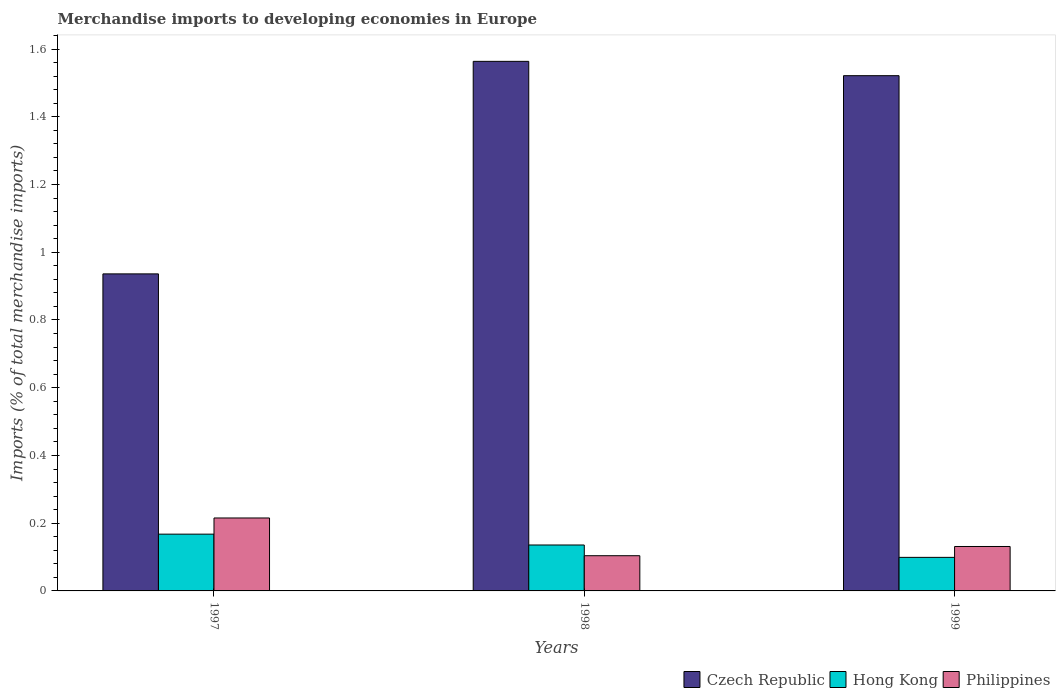How many different coloured bars are there?
Your response must be concise. 3. How many bars are there on the 2nd tick from the right?
Make the answer very short. 3. What is the percentage total merchandise imports in Philippines in 1997?
Provide a short and direct response. 0.22. Across all years, what is the maximum percentage total merchandise imports in Philippines?
Offer a very short reply. 0.22. Across all years, what is the minimum percentage total merchandise imports in Hong Kong?
Keep it short and to the point. 0.1. In which year was the percentage total merchandise imports in Hong Kong maximum?
Give a very brief answer. 1997. What is the total percentage total merchandise imports in Czech Republic in the graph?
Provide a short and direct response. 4.02. What is the difference between the percentage total merchandise imports in Czech Republic in 1997 and that in 1998?
Your answer should be very brief. -0.63. What is the difference between the percentage total merchandise imports in Czech Republic in 1998 and the percentage total merchandise imports in Hong Kong in 1999?
Ensure brevity in your answer.  1.46. What is the average percentage total merchandise imports in Philippines per year?
Your answer should be very brief. 0.15. In the year 1999, what is the difference between the percentage total merchandise imports in Hong Kong and percentage total merchandise imports in Philippines?
Keep it short and to the point. -0.03. In how many years, is the percentage total merchandise imports in Hong Kong greater than 0.9600000000000001 %?
Give a very brief answer. 0. What is the ratio of the percentage total merchandise imports in Philippines in 1997 to that in 1998?
Ensure brevity in your answer.  2.07. Is the percentage total merchandise imports in Czech Republic in 1997 less than that in 1999?
Ensure brevity in your answer.  Yes. Is the difference between the percentage total merchandise imports in Hong Kong in 1997 and 1999 greater than the difference between the percentage total merchandise imports in Philippines in 1997 and 1999?
Offer a terse response. No. What is the difference between the highest and the second highest percentage total merchandise imports in Czech Republic?
Offer a very short reply. 0.04. What is the difference between the highest and the lowest percentage total merchandise imports in Philippines?
Give a very brief answer. 0.11. Is the sum of the percentage total merchandise imports in Philippines in 1997 and 1998 greater than the maximum percentage total merchandise imports in Hong Kong across all years?
Keep it short and to the point. Yes. What does the 1st bar from the left in 1998 represents?
Keep it short and to the point. Czech Republic. What does the 2nd bar from the right in 1998 represents?
Provide a short and direct response. Hong Kong. Is it the case that in every year, the sum of the percentage total merchandise imports in Hong Kong and percentage total merchandise imports in Czech Republic is greater than the percentage total merchandise imports in Philippines?
Ensure brevity in your answer.  Yes. How many bars are there?
Offer a terse response. 9. What is the difference between two consecutive major ticks on the Y-axis?
Your answer should be very brief. 0.2. Are the values on the major ticks of Y-axis written in scientific E-notation?
Keep it short and to the point. No. Does the graph contain grids?
Your answer should be compact. No. What is the title of the graph?
Ensure brevity in your answer.  Merchandise imports to developing economies in Europe. What is the label or title of the X-axis?
Your answer should be very brief. Years. What is the label or title of the Y-axis?
Give a very brief answer. Imports (% of total merchandise imports). What is the Imports (% of total merchandise imports) of Czech Republic in 1997?
Provide a short and direct response. 0.94. What is the Imports (% of total merchandise imports) in Hong Kong in 1997?
Provide a short and direct response. 0.17. What is the Imports (% of total merchandise imports) in Philippines in 1997?
Your answer should be very brief. 0.22. What is the Imports (% of total merchandise imports) in Czech Republic in 1998?
Provide a succinct answer. 1.56. What is the Imports (% of total merchandise imports) of Hong Kong in 1998?
Give a very brief answer. 0.14. What is the Imports (% of total merchandise imports) of Philippines in 1998?
Keep it short and to the point. 0.1. What is the Imports (% of total merchandise imports) in Czech Republic in 1999?
Your answer should be very brief. 1.52. What is the Imports (% of total merchandise imports) of Hong Kong in 1999?
Provide a short and direct response. 0.1. What is the Imports (% of total merchandise imports) in Philippines in 1999?
Provide a short and direct response. 0.13. Across all years, what is the maximum Imports (% of total merchandise imports) in Czech Republic?
Make the answer very short. 1.56. Across all years, what is the maximum Imports (% of total merchandise imports) of Hong Kong?
Make the answer very short. 0.17. Across all years, what is the maximum Imports (% of total merchandise imports) of Philippines?
Your response must be concise. 0.22. Across all years, what is the minimum Imports (% of total merchandise imports) in Czech Republic?
Keep it short and to the point. 0.94. Across all years, what is the minimum Imports (% of total merchandise imports) of Hong Kong?
Provide a succinct answer. 0.1. Across all years, what is the minimum Imports (% of total merchandise imports) of Philippines?
Your answer should be compact. 0.1. What is the total Imports (% of total merchandise imports) of Czech Republic in the graph?
Provide a succinct answer. 4.02. What is the total Imports (% of total merchandise imports) in Hong Kong in the graph?
Provide a succinct answer. 0.4. What is the total Imports (% of total merchandise imports) in Philippines in the graph?
Your answer should be compact. 0.45. What is the difference between the Imports (% of total merchandise imports) in Czech Republic in 1997 and that in 1998?
Offer a very short reply. -0.63. What is the difference between the Imports (% of total merchandise imports) in Hong Kong in 1997 and that in 1998?
Your answer should be very brief. 0.03. What is the difference between the Imports (% of total merchandise imports) of Philippines in 1997 and that in 1998?
Offer a terse response. 0.11. What is the difference between the Imports (% of total merchandise imports) of Czech Republic in 1997 and that in 1999?
Your answer should be compact. -0.59. What is the difference between the Imports (% of total merchandise imports) in Hong Kong in 1997 and that in 1999?
Your answer should be compact. 0.07. What is the difference between the Imports (% of total merchandise imports) of Philippines in 1997 and that in 1999?
Provide a short and direct response. 0.08. What is the difference between the Imports (% of total merchandise imports) in Czech Republic in 1998 and that in 1999?
Keep it short and to the point. 0.04. What is the difference between the Imports (% of total merchandise imports) in Hong Kong in 1998 and that in 1999?
Make the answer very short. 0.04. What is the difference between the Imports (% of total merchandise imports) of Philippines in 1998 and that in 1999?
Keep it short and to the point. -0.03. What is the difference between the Imports (% of total merchandise imports) in Czech Republic in 1997 and the Imports (% of total merchandise imports) in Hong Kong in 1998?
Give a very brief answer. 0.8. What is the difference between the Imports (% of total merchandise imports) of Czech Republic in 1997 and the Imports (% of total merchandise imports) of Philippines in 1998?
Your answer should be very brief. 0.83. What is the difference between the Imports (% of total merchandise imports) of Hong Kong in 1997 and the Imports (% of total merchandise imports) of Philippines in 1998?
Your answer should be compact. 0.06. What is the difference between the Imports (% of total merchandise imports) in Czech Republic in 1997 and the Imports (% of total merchandise imports) in Hong Kong in 1999?
Make the answer very short. 0.84. What is the difference between the Imports (% of total merchandise imports) in Czech Republic in 1997 and the Imports (% of total merchandise imports) in Philippines in 1999?
Your response must be concise. 0.81. What is the difference between the Imports (% of total merchandise imports) of Hong Kong in 1997 and the Imports (% of total merchandise imports) of Philippines in 1999?
Make the answer very short. 0.04. What is the difference between the Imports (% of total merchandise imports) of Czech Republic in 1998 and the Imports (% of total merchandise imports) of Hong Kong in 1999?
Provide a short and direct response. 1.46. What is the difference between the Imports (% of total merchandise imports) of Czech Republic in 1998 and the Imports (% of total merchandise imports) of Philippines in 1999?
Your response must be concise. 1.43. What is the difference between the Imports (% of total merchandise imports) of Hong Kong in 1998 and the Imports (% of total merchandise imports) of Philippines in 1999?
Ensure brevity in your answer.  0. What is the average Imports (% of total merchandise imports) of Czech Republic per year?
Make the answer very short. 1.34. What is the average Imports (% of total merchandise imports) of Hong Kong per year?
Your answer should be compact. 0.13. What is the average Imports (% of total merchandise imports) of Philippines per year?
Your response must be concise. 0.15. In the year 1997, what is the difference between the Imports (% of total merchandise imports) in Czech Republic and Imports (% of total merchandise imports) in Hong Kong?
Your answer should be compact. 0.77. In the year 1997, what is the difference between the Imports (% of total merchandise imports) in Czech Republic and Imports (% of total merchandise imports) in Philippines?
Offer a terse response. 0.72. In the year 1997, what is the difference between the Imports (% of total merchandise imports) in Hong Kong and Imports (% of total merchandise imports) in Philippines?
Provide a short and direct response. -0.05. In the year 1998, what is the difference between the Imports (% of total merchandise imports) in Czech Republic and Imports (% of total merchandise imports) in Hong Kong?
Ensure brevity in your answer.  1.43. In the year 1998, what is the difference between the Imports (% of total merchandise imports) in Czech Republic and Imports (% of total merchandise imports) in Philippines?
Your response must be concise. 1.46. In the year 1998, what is the difference between the Imports (% of total merchandise imports) of Hong Kong and Imports (% of total merchandise imports) of Philippines?
Your answer should be compact. 0.03. In the year 1999, what is the difference between the Imports (% of total merchandise imports) in Czech Republic and Imports (% of total merchandise imports) in Hong Kong?
Make the answer very short. 1.42. In the year 1999, what is the difference between the Imports (% of total merchandise imports) in Czech Republic and Imports (% of total merchandise imports) in Philippines?
Keep it short and to the point. 1.39. In the year 1999, what is the difference between the Imports (% of total merchandise imports) of Hong Kong and Imports (% of total merchandise imports) of Philippines?
Your answer should be very brief. -0.03. What is the ratio of the Imports (% of total merchandise imports) in Czech Republic in 1997 to that in 1998?
Keep it short and to the point. 0.6. What is the ratio of the Imports (% of total merchandise imports) in Hong Kong in 1997 to that in 1998?
Your answer should be compact. 1.24. What is the ratio of the Imports (% of total merchandise imports) in Philippines in 1997 to that in 1998?
Ensure brevity in your answer.  2.07. What is the ratio of the Imports (% of total merchandise imports) in Czech Republic in 1997 to that in 1999?
Provide a short and direct response. 0.62. What is the ratio of the Imports (% of total merchandise imports) in Hong Kong in 1997 to that in 1999?
Ensure brevity in your answer.  1.69. What is the ratio of the Imports (% of total merchandise imports) in Philippines in 1997 to that in 1999?
Offer a very short reply. 1.64. What is the ratio of the Imports (% of total merchandise imports) of Czech Republic in 1998 to that in 1999?
Your answer should be very brief. 1.03. What is the ratio of the Imports (% of total merchandise imports) of Hong Kong in 1998 to that in 1999?
Provide a succinct answer. 1.37. What is the ratio of the Imports (% of total merchandise imports) in Philippines in 1998 to that in 1999?
Keep it short and to the point. 0.79. What is the difference between the highest and the second highest Imports (% of total merchandise imports) of Czech Republic?
Give a very brief answer. 0.04. What is the difference between the highest and the second highest Imports (% of total merchandise imports) in Hong Kong?
Provide a short and direct response. 0.03. What is the difference between the highest and the second highest Imports (% of total merchandise imports) in Philippines?
Give a very brief answer. 0.08. What is the difference between the highest and the lowest Imports (% of total merchandise imports) in Czech Republic?
Your response must be concise. 0.63. What is the difference between the highest and the lowest Imports (% of total merchandise imports) of Hong Kong?
Your response must be concise. 0.07. What is the difference between the highest and the lowest Imports (% of total merchandise imports) of Philippines?
Provide a short and direct response. 0.11. 